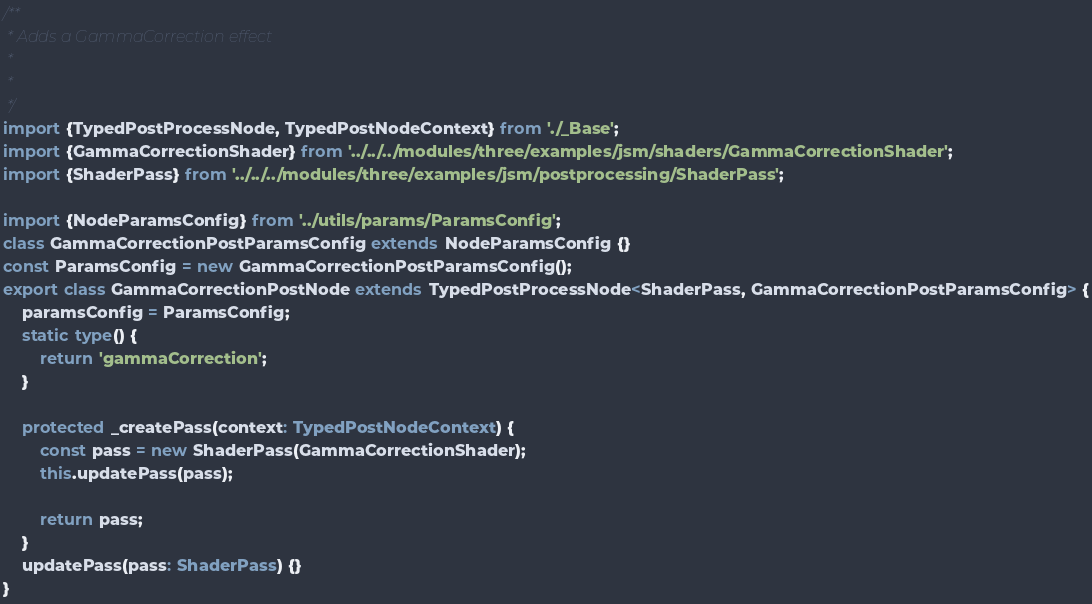<code> <loc_0><loc_0><loc_500><loc_500><_TypeScript_>/**
 * Adds a GammaCorrection effect
 *
 *
 */
import {TypedPostProcessNode, TypedPostNodeContext} from './_Base';
import {GammaCorrectionShader} from '../../../modules/three/examples/jsm/shaders/GammaCorrectionShader';
import {ShaderPass} from '../../../modules/three/examples/jsm/postprocessing/ShaderPass';

import {NodeParamsConfig} from '../utils/params/ParamsConfig';
class GammaCorrectionPostParamsConfig extends NodeParamsConfig {}
const ParamsConfig = new GammaCorrectionPostParamsConfig();
export class GammaCorrectionPostNode extends TypedPostProcessNode<ShaderPass, GammaCorrectionPostParamsConfig> {
	paramsConfig = ParamsConfig;
	static type() {
		return 'gammaCorrection';
	}

	protected _createPass(context: TypedPostNodeContext) {
		const pass = new ShaderPass(GammaCorrectionShader);
		this.updatePass(pass);

		return pass;
	}
	updatePass(pass: ShaderPass) {}
}
</code> 